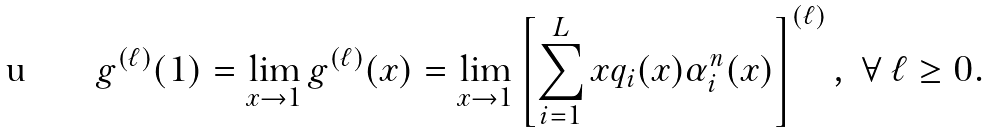<formula> <loc_0><loc_0><loc_500><loc_500>g ^ { ( \ell ) } ( 1 ) = \lim _ { x \rightarrow 1 } g ^ { ( \ell ) } ( x ) = \lim _ { x \rightarrow 1 } \left [ \sum _ { i = 1 } ^ { L } x q _ { i } ( x ) \alpha _ { i } ^ { n } ( x ) \right ] ^ { ( \ell ) } , \ \forall \ \ell \geq 0 .</formula> 